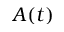Convert formula to latex. <formula><loc_0><loc_0><loc_500><loc_500>A ( t )</formula> 